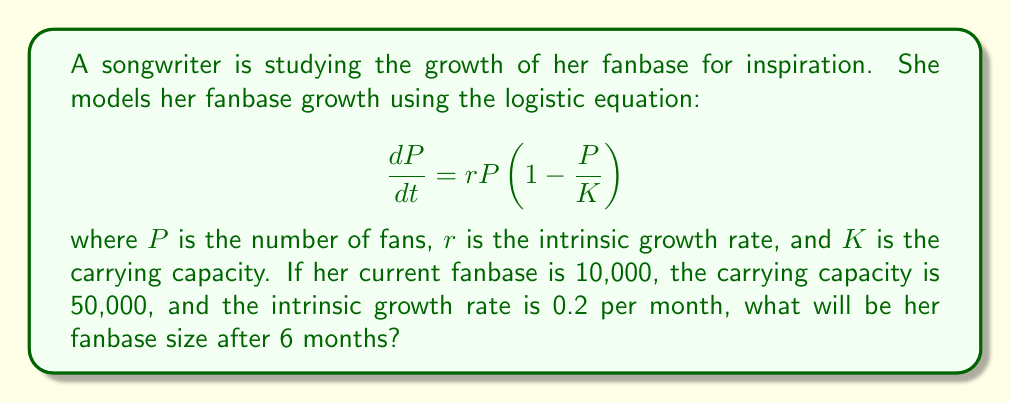Give your solution to this math problem. To solve this problem, we need to use the solution to the logistic equation, which is:

$$P(t) = \frac{K}{1 + (\frac{K}{P_0} - 1)e^{-rt}}$$

Where:
$P(t)$ is the population at time $t$
$K$ is the carrying capacity
$P_0$ is the initial population
$r$ is the intrinsic growth rate
$t$ is the time

Given:
$K = 50,000$
$P_0 = 10,000$
$r = 0.2$ per month
$t = 6$ months

Let's substitute these values into the equation:

$$P(6) = \frac{50,000}{1 + (\frac{50,000}{10,000} - 1)e^{-0.2 \times 6}}$$

$$= \frac{50,000}{1 + (5 - 1)e^{-1.2}}$$

$$= \frac{50,000}{1 + 4e^{-1.2}}$$

Now, let's calculate:

$e^{-1.2} \approx 0.3012$

$$P(6) = \frac{50,000}{1 + 4 \times 0.3012}$$

$$= \frac{50,000}{2.2048}$$

$$\approx 22,678.7$$

Rounding to the nearest whole number, as we can't have a fractional number of fans:
Answer: 22,679 fans 